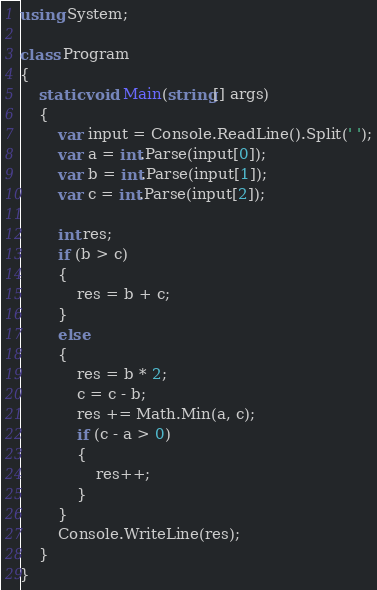Convert code to text. <code><loc_0><loc_0><loc_500><loc_500><_C#_>using System;

class Program
{
    static void Main(string[] args)
    {
        var input = Console.ReadLine().Split(' ');
        var a = int.Parse(input[0]);
        var b = int.Parse(input[1]);
        var c = int.Parse(input[2]);

        int res;
        if (b > c)
        {
            res = b + c;
        }
        else
        {
            res = b * 2;
            c = c - b;
            res += Math.Min(a, c);
            if (c - a > 0)
            {
                res++;
            }
        }
        Console.WriteLine(res);
    }
}</code> 